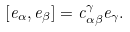Convert formula to latex. <formula><loc_0><loc_0><loc_500><loc_500>[ e _ { \alpha } , e _ { \beta } ] = c ^ { \gamma } _ { \alpha \beta } e _ { \gamma } .</formula> 